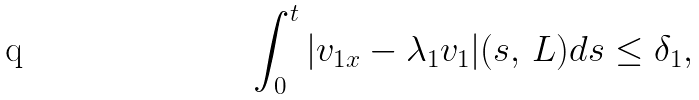Convert formula to latex. <formula><loc_0><loc_0><loc_500><loc_500>\int _ { 0 } ^ { t } | v _ { 1 x } - \lambda _ { 1 } v _ { 1 } | ( s , \, L ) d s \leq \delta _ { 1 } ,</formula> 